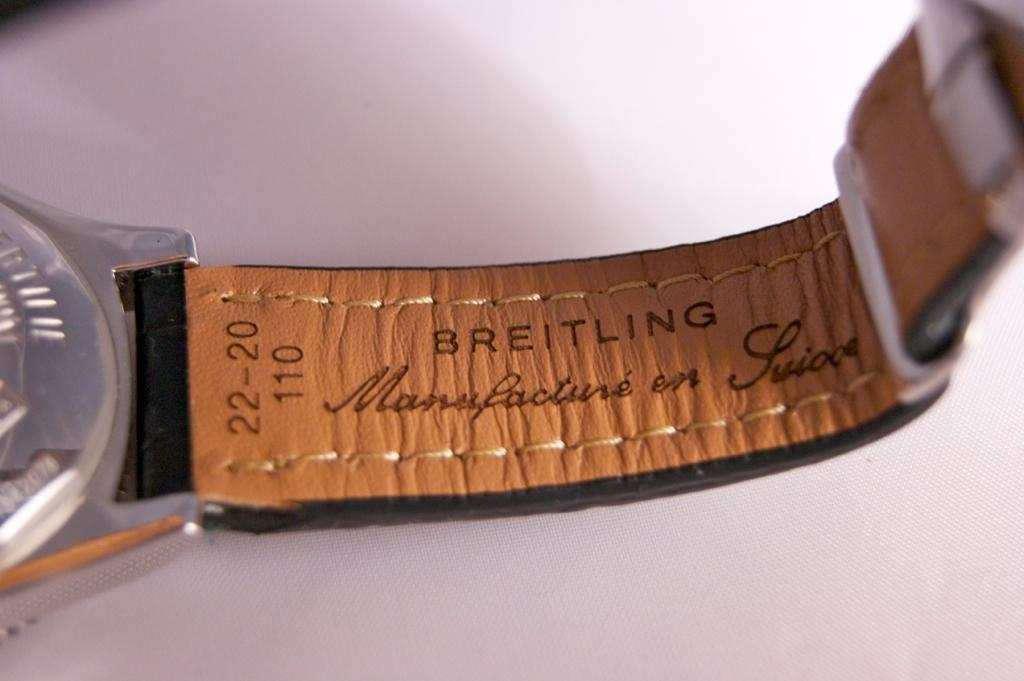<image>
Describe the image concisely. A Breitling watch is laying on a table. 